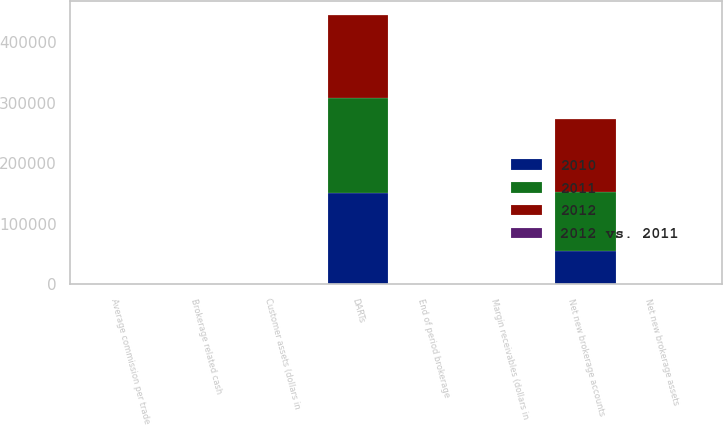<chart> <loc_0><loc_0><loc_500><loc_500><stacked_bar_chart><ecel><fcel>DARTs<fcel>Average commission per trade<fcel>Margin receivables (dollars in<fcel>End of period brokerage<fcel>Net new brokerage accounts<fcel>Customer assets (dollars in<fcel>Net new brokerage assets<fcel>Brokerage related cash<nl><fcel>2012<fcel>138112<fcel>11.01<fcel>5.8<fcel>21<fcel>120179<fcel>201.2<fcel>10.4<fcel>33.9<nl><fcel>2011<fcel>157475<fcel>11.01<fcel>4.8<fcel>21<fcel>98701<fcel>172.4<fcel>9.7<fcel>27.7<nl><fcel>2010<fcel>150532<fcel>11.21<fcel>5.1<fcel>21<fcel>54232<fcel>176.2<fcel>8.1<fcel>24.5<nl><fcel>2012 vs. 2011<fcel>12<fcel>0<fcel>21<fcel>4<fcel>22<fcel>17<fcel>7<fcel>22<nl></chart> 